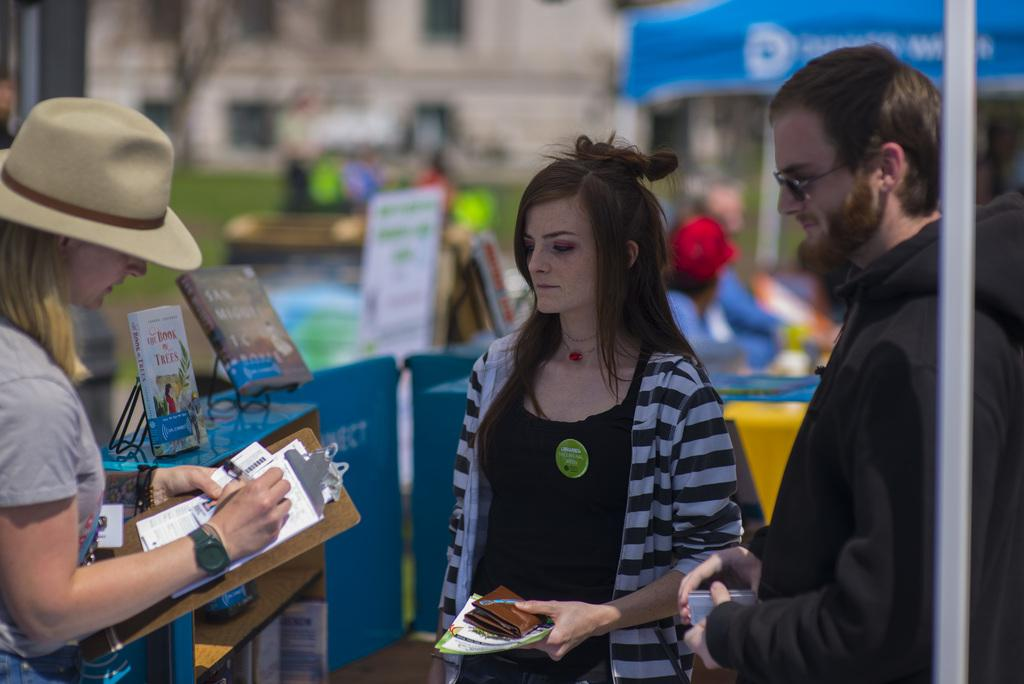How many people are present in the image? There are three people in the image. What are the people doing in the image? The people are holding objects. What can be seen in the background of the image? There are tables and buildings in the background of the image. What type of fruit is being transported by the truck in the image? There is no truck present in the image, so it is not possible to determine what type of fruit might be transported. 